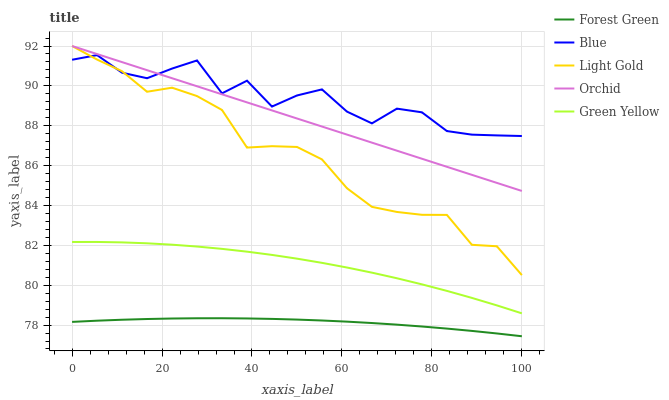Does Green Yellow have the minimum area under the curve?
Answer yes or no. No. Does Green Yellow have the maximum area under the curve?
Answer yes or no. No. Is Forest Green the smoothest?
Answer yes or no. No. Is Forest Green the roughest?
Answer yes or no. No. Does Green Yellow have the lowest value?
Answer yes or no. No. Does Green Yellow have the highest value?
Answer yes or no. No. Is Green Yellow less than Orchid?
Answer yes or no. Yes. Is Orchid greater than Forest Green?
Answer yes or no. Yes. Does Green Yellow intersect Orchid?
Answer yes or no. No. 